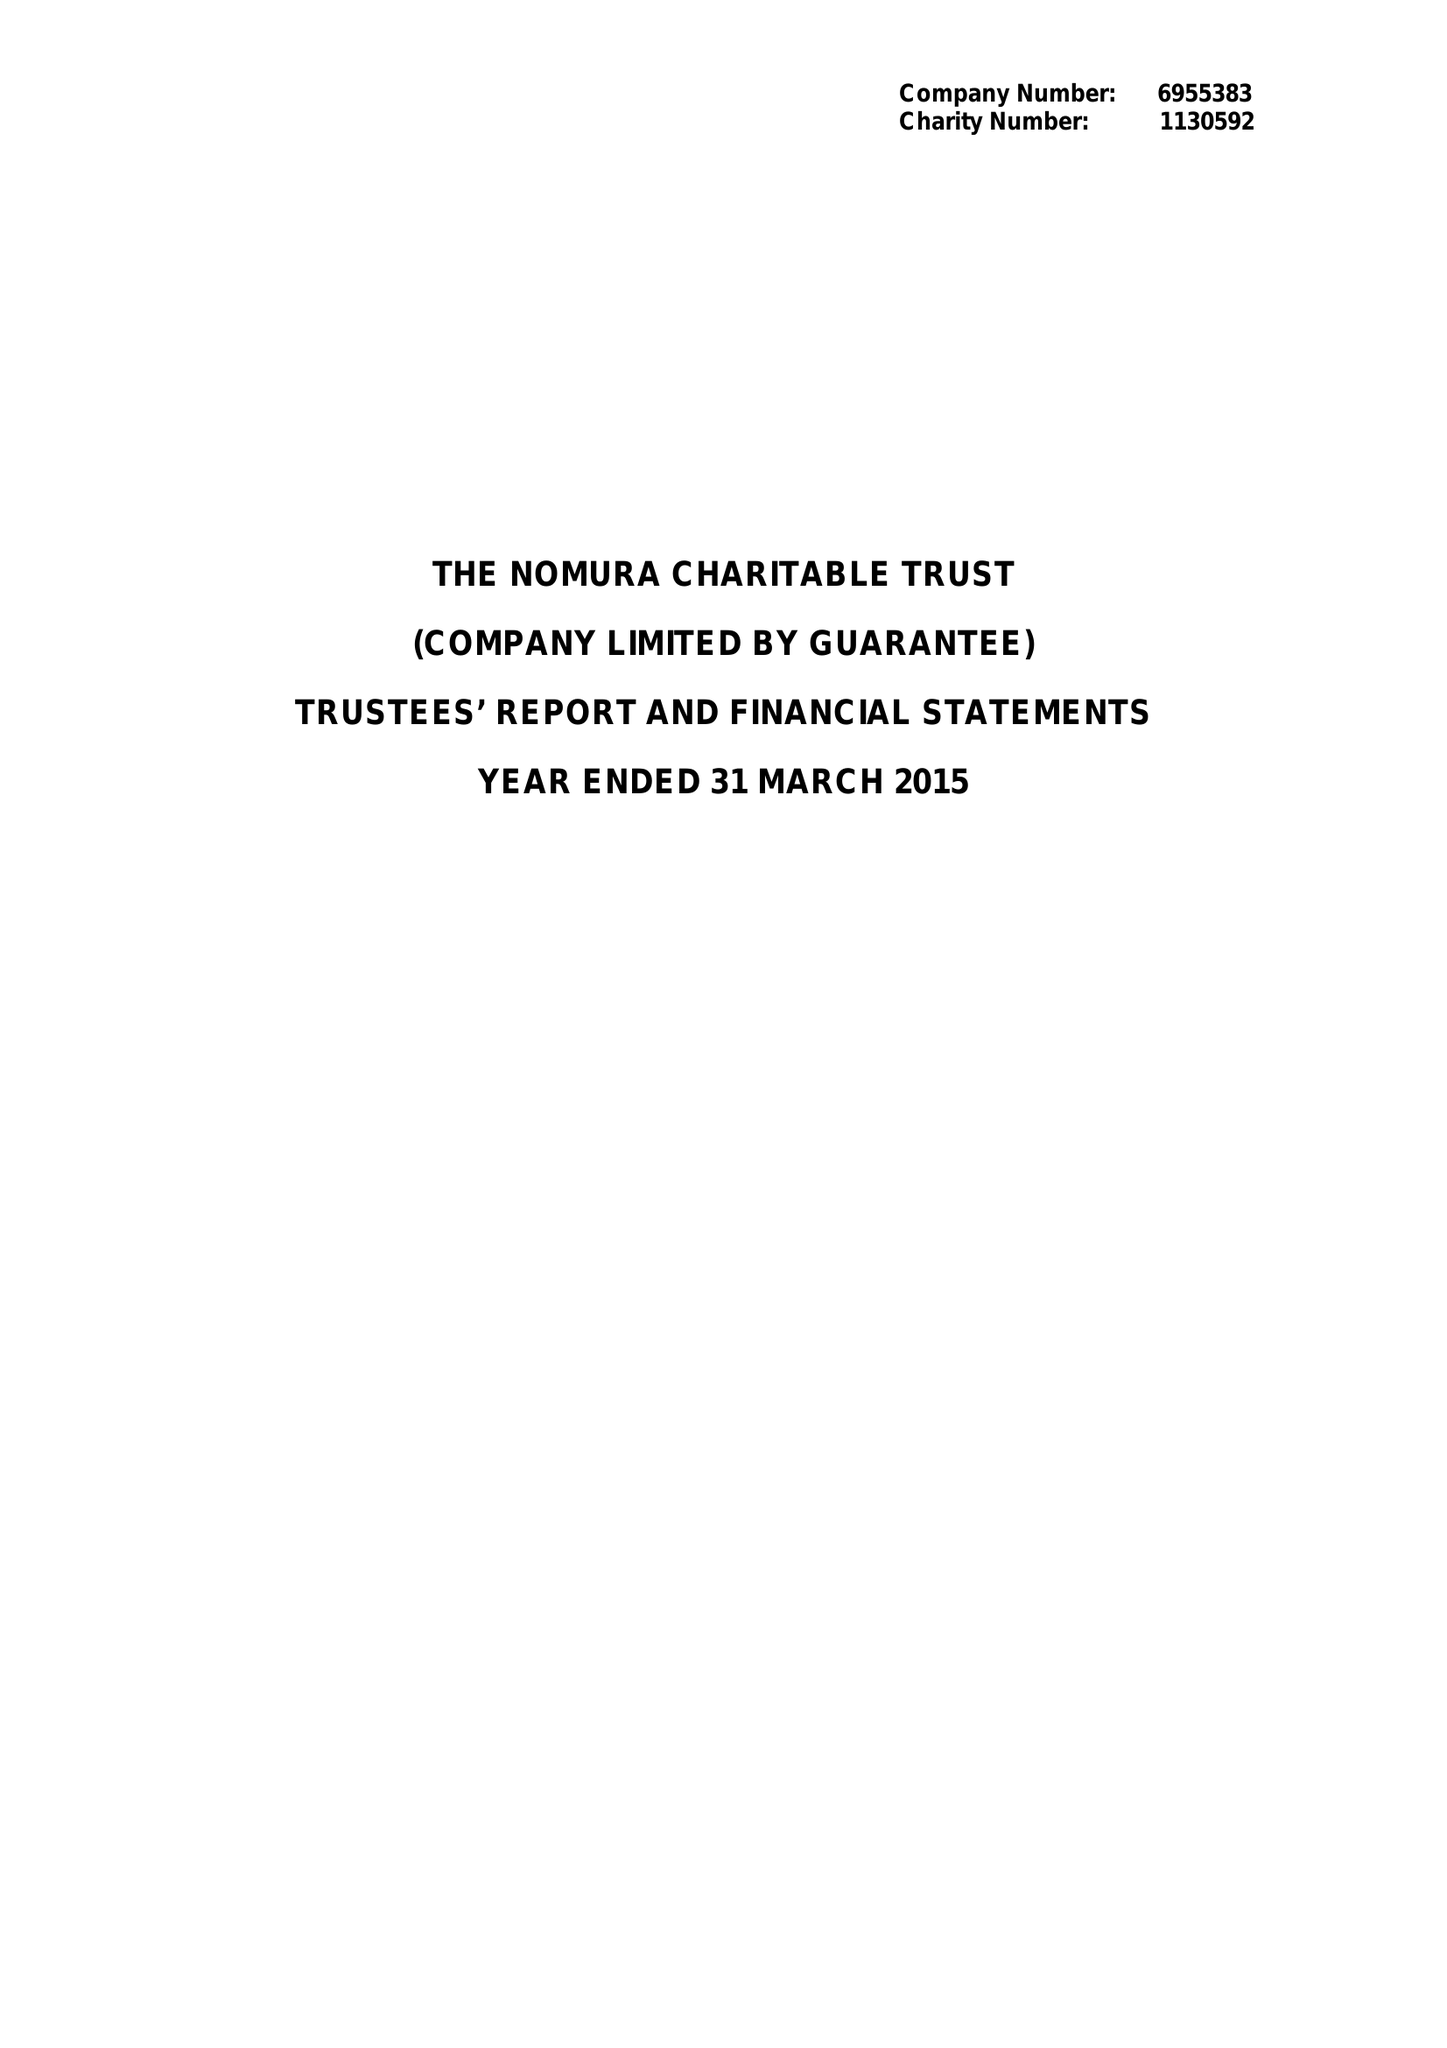What is the value for the address__postcode?
Answer the question using a single word or phrase. EC4R 3AB 